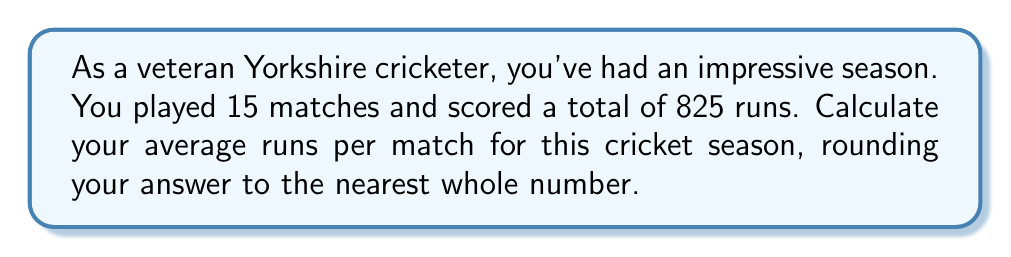Teach me how to tackle this problem. To calculate the average runs per match, we need to use the formula:

$$ \text{Average} = \frac{\text{Total Runs}}{\text{Number of Matches}} $$

Given:
- Total runs scored: 825
- Number of matches played: 15

Let's substitute these values into our formula:

$$ \text{Average} = \frac{825}{15} $$

Now, let's perform the division:

$$ \text{Average} = 55 $$

Since the question asks to round to the nearest whole number, and 55 is already a whole number, no further rounding is necessary.
Answer: $55$ runs per match 